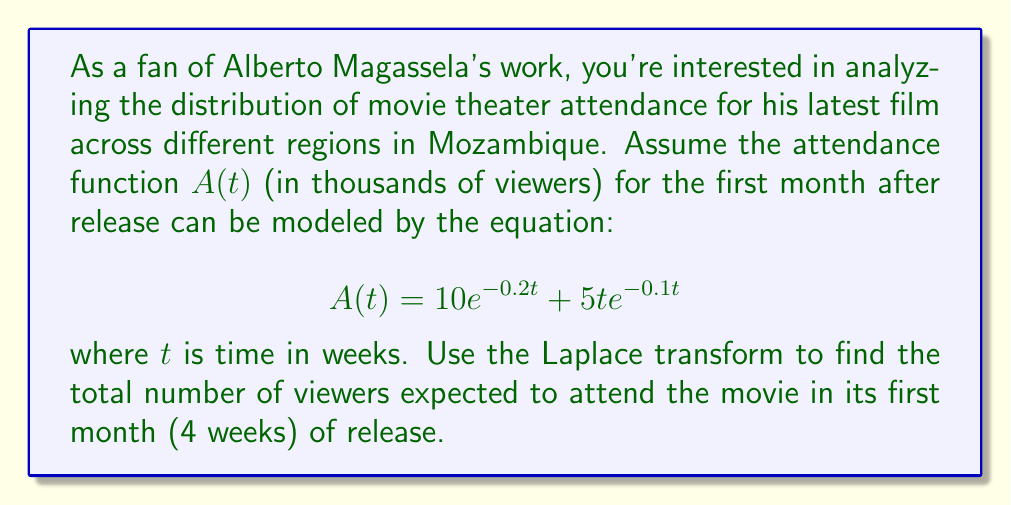Can you solve this math problem? To solve this problem, we'll follow these steps:

1) First, let's recall the Laplace transform of $A(t)$:
   $$\mathcal{L}\{A(t)\} = \int_0^\infty A(t)e^{-st}dt$$

2) We need to find the Laplace transforms of the two terms in $A(t)$:
   
   a) For $10e^{-0.2t}$:
      $$\mathcal{L}\{10e^{-0.2t}\} = \frac{10}{s+0.2}$$
   
   b) For $5te^{-0.1t}$:
      $$\mathcal{L}\{5te^{-0.1t}\} = \frac{5}{(s+0.1)^2}$$

3) Therefore, the Laplace transform of $A(t)$ is:
   $$\mathcal{L}\{A(t)\} = \frac{10}{s+0.2} + \frac{5}{(s+0.1)^2}$$

4) To find the total number of viewers over 4 weeks, we need to integrate $A(t)$ from 0 to 4. In the s-domain, this is equivalent to:

   $$\int_0^4 A(t)dt = \frac{1}{s}\mathcal{L}\{A(t)\}\bigg|_{s=0}$$

5) Substituting $s=0$ into our Laplace transform:

   $$\frac{1}{s}\left(\frac{10}{s+0.2} + \frac{5}{(s+0.1)^2}\right)\bigg|_{s=0}$$
   
   $$= \frac{10}{0.2} + \frac{5}{(0.1)^2} = 50 + 500 = 550$$

Therefore, the total number of viewers expected in the first month is 550 thousand.
Answer: 550 thousand viewers 